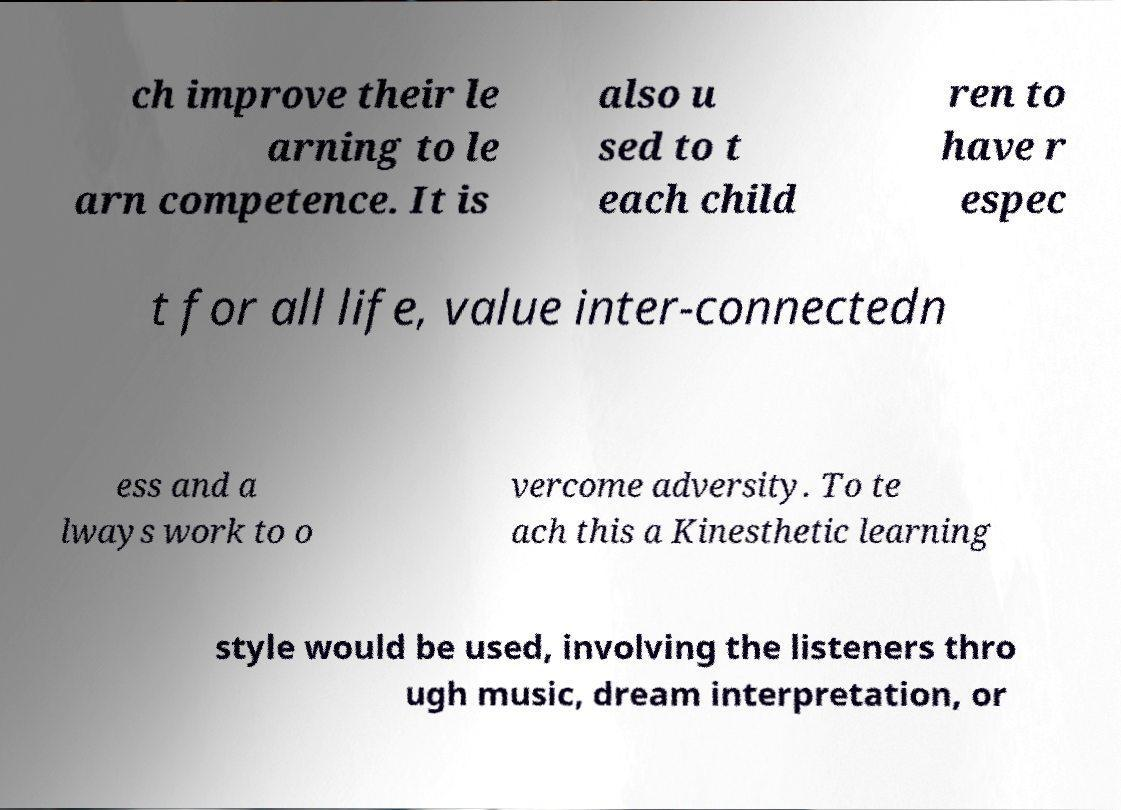Could you assist in decoding the text presented in this image and type it out clearly? ch improve their le arning to le arn competence. It is also u sed to t each child ren to have r espec t for all life, value inter-connectedn ess and a lways work to o vercome adversity. To te ach this a Kinesthetic learning style would be used, involving the listeners thro ugh music, dream interpretation, or 